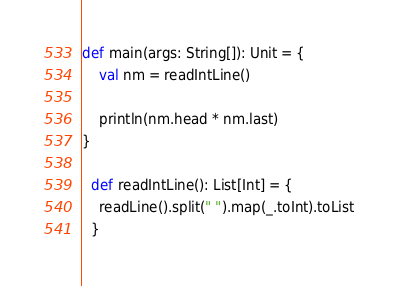Convert code to text. <code><loc_0><loc_0><loc_500><loc_500><_Scala_>def main(args: String[]): Unit = {
	val nm = readIntLine()

    println(nm.head * nm.last)
}

  def readIntLine(): List[Int] = {
    readLine().split(" ").map(_.toInt).toList
  }</code> 